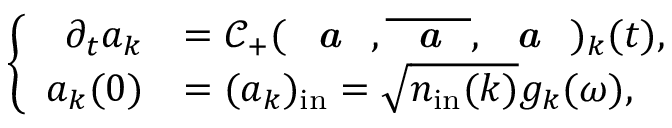<formula> <loc_0><loc_0><loc_500><loc_500>\left \{ \begin{array} { r l } { \partial _ { t } a _ { k } } & { = \mathcal { C } _ { + } ( a , \overline { a } , a ) _ { k } ( t ) , } \\ { a _ { k } ( 0 ) } & { = ( a _ { k } ) _ { i n } = \sqrt { n _ { i n } ( k ) } g _ { k } ( \omega ) , } \end{array}</formula> 